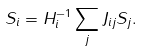<formula> <loc_0><loc_0><loc_500><loc_500>S _ { i } = H _ { i } ^ { - 1 } \sum _ { j } J _ { i j } S _ { j } .</formula> 